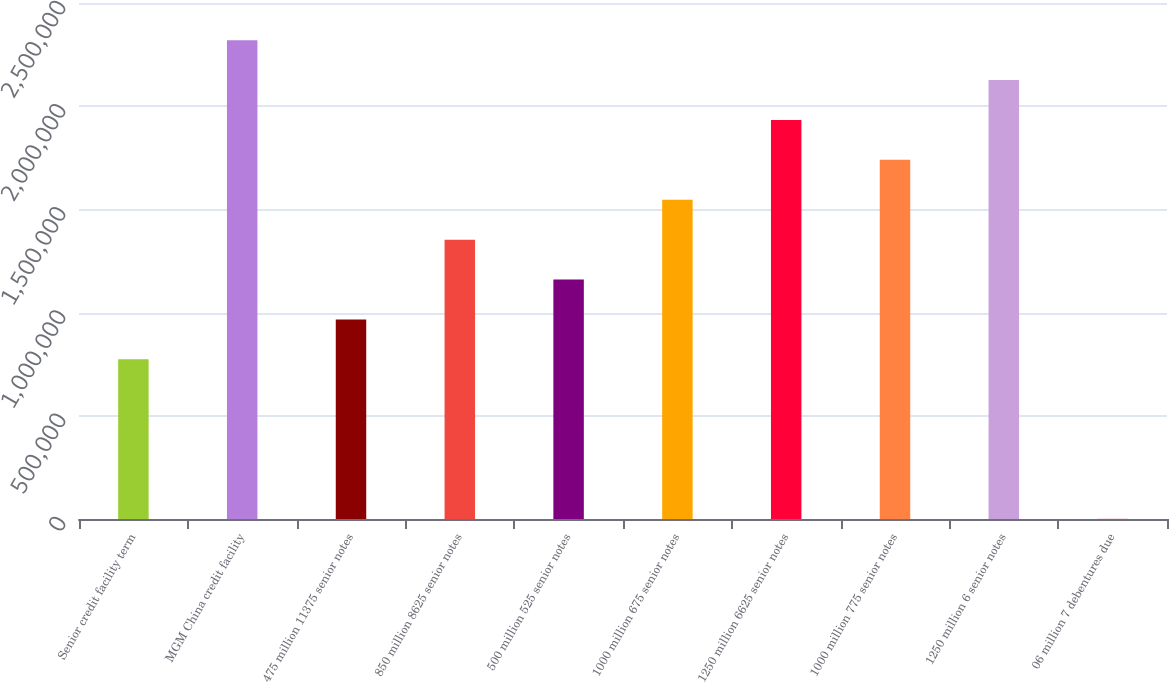Convert chart to OTSL. <chart><loc_0><loc_0><loc_500><loc_500><bar_chart><fcel>Senior credit facility term<fcel>MGM China credit facility<fcel>475 million 11375 senior notes<fcel>850 million 8625 senior notes<fcel>500 million 525 senior notes<fcel>1000 million 675 senior notes<fcel>1250 million 6625 senior notes<fcel>1000 million 775 senior notes<fcel>1250 million 6 senior notes<fcel>06 million 7 debentures due<nl><fcel>773656<fcel>2.31987e+06<fcel>966932<fcel>1.35348e+06<fcel>1.16021e+06<fcel>1.54676e+06<fcel>1.93331e+06<fcel>1.74004e+06<fcel>2.12659e+06<fcel>552<nl></chart> 